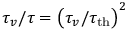Convert formula to latex. <formula><loc_0><loc_0><loc_500><loc_500>\tau _ { v } / \tau = \left ( \tau _ { v } / \tau _ { t h } \right ) ^ { 2 }</formula> 